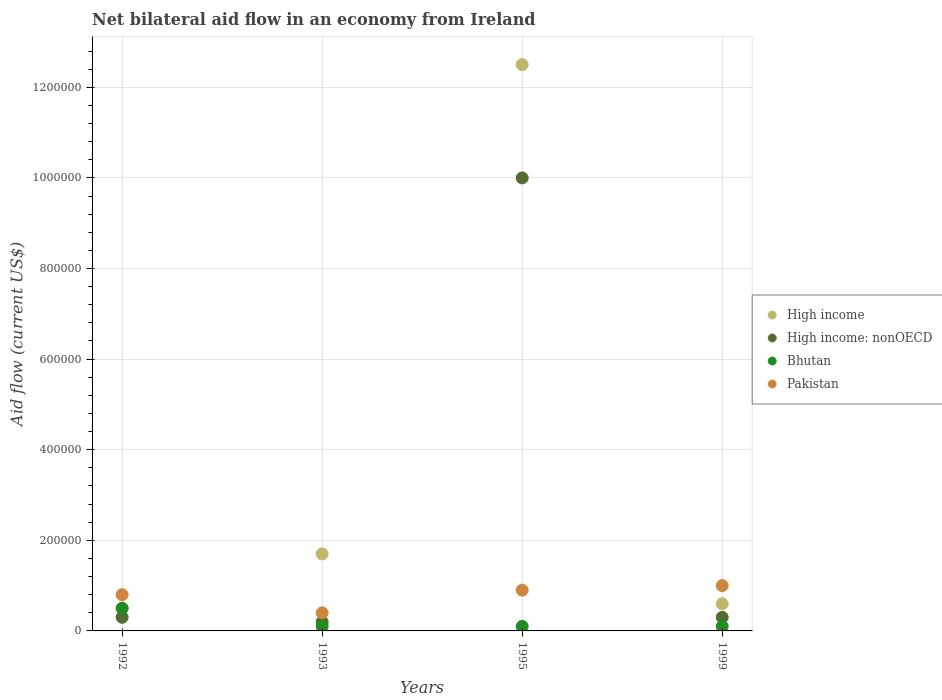How many different coloured dotlines are there?
Your answer should be very brief. 4. Across all years, what is the maximum net bilateral aid flow in High income: nonOECD?
Make the answer very short. 1.00e+06. Across all years, what is the minimum net bilateral aid flow in Bhutan?
Provide a short and direct response. 10000. In which year was the net bilateral aid flow in High income: nonOECD maximum?
Your response must be concise. 1995. In which year was the net bilateral aid flow in High income: nonOECD minimum?
Offer a very short reply. 1993. What is the difference between the net bilateral aid flow in High income: nonOECD in 1992 and that in 1995?
Keep it short and to the point. -9.70e+05. What is the difference between the net bilateral aid flow in Pakistan in 1992 and the net bilateral aid flow in High income in 1995?
Offer a very short reply. -1.17e+06. What is the average net bilateral aid flow in High income: nonOECD per year?
Your answer should be very brief. 2.70e+05. What is the ratio of the net bilateral aid flow in High income in 1993 to that in 1995?
Ensure brevity in your answer.  0.14. What is the difference between the highest and the second highest net bilateral aid flow in High income?
Your answer should be very brief. 1.08e+06. What is the difference between the highest and the lowest net bilateral aid flow in High income: nonOECD?
Your response must be concise. 9.80e+05. In how many years, is the net bilateral aid flow in High income: nonOECD greater than the average net bilateral aid flow in High income: nonOECD taken over all years?
Keep it short and to the point. 1. Is it the case that in every year, the sum of the net bilateral aid flow in High income: nonOECD and net bilateral aid flow in Bhutan  is greater than the sum of net bilateral aid flow in High income and net bilateral aid flow in Pakistan?
Provide a succinct answer. No. Does the net bilateral aid flow in Pakistan monotonically increase over the years?
Give a very brief answer. No. Is the net bilateral aid flow in Pakistan strictly greater than the net bilateral aid flow in Bhutan over the years?
Ensure brevity in your answer.  Yes. How many dotlines are there?
Make the answer very short. 4. What is the difference between two consecutive major ticks on the Y-axis?
Offer a very short reply. 2.00e+05. Are the values on the major ticks of Y-axis written in scientific E-notation?
Make the answer very short. No. Does the graph contain any zero values?
Ensure brevity in your answer.  No. How many legend labels are there?
Give a very brief answer. 4. What is the title of the graph?
Your answer should be compact. Net bilateral aid flow in an economy from Ireland. Does "Jamaica" appear as one of the legend labels in the graph?
Keep it short and to the point. No. What is the label or title of the X-axis?
Give a very brief answer. Years. What is the Aid flow (current US$) in Pakistan in 1992?
Provide a short and direct response. 8.00e+04. What is the Aid flow (current US$) in High income in 1993?
Your answer should be very brief. 1.70e+05. What is the Aid flow (current US$) of Bhutan in 1993?
Offer a very short reply. 10000. What is the Aid flow (current US$) in High income in 1995?
Provide a short and direct response. 1.25e+06. What is the Aid flow (current US$) in High income: nonOECD in 1995?
Keep it short and to the point. 1.00e+06. What is the Aid flow (current US$) in Bhutan in 1995?
Ensure brevity in your answer.  10000. What is the Aid flow (current US$) of High income in 1999?
Keep it short and to the point. 6.00e+04. What is the Aid flow (current US$) in Bhutan in 1999?
Ensure brevity in your answer.  10000. Across all years, what is the maximum Aid flow (current US$) in High income?
Your response must be concise. 1.25e+06. Across all years, what is the maximum Aid flow (current US$) of Bhutan?
Ensure brevity in your answer.  5.00e+04. Across all years, what is the maximum Aid flow (current US$) of Pakistan?
Offer a very short reply. 1.00e+05. Across all years, what is the minimum Aid flow (current US$) of High income?
Provide a short and direct response. 5.00e+04. What is the total Aid flow (current US$) in High income in the graph?
Provide a succinct answer. 1.53e+06. What is the total Aid flow (current US$) of High income: nonOECD in the graph?
Offer a very short reply. 1.08e+06. What is the total Aid flow (current US$) of Pakistan in the graph?
Make the answer very short. 3.10e+05. What is the difference between the Aid flow (current US$) of Bhutan in 1992 and that in 1993?
Offer a terse response. 4.00e+04. What is the difference between the Aid flow (current US$) of High income in 1992 and that in 1995?
Provide a short and direct response. -1.20e+06. What is the difference between the Aid flow (current US$) of High income: nonOECD in 1992 and that in 1995?
Give a very brief answer. -9.70e+05. What is the difference between the Aid flow (current US$) in Pakistan in 1992 and that in 1995?
Offer a terse response. -10000. What is the difference between the Aid flow (current US$) of High income in 1992 and that in 1999?
Keep it short and to the point. -10000. What is the difference between the Aid flow (current US$) of High income: nonOECD in 1992 and that in 1999?
Make the answer very short. 0. What is the difference between the Aid flow (current US$) of High income in 1993 and that in 1995?
Ensure brevity in your answer.  -1.08e+06. What is the difference between the Aid flow (current US$) in High income: nonOECD in 1993 and that in 1995?
Provide a short and direct response. -9.80e+05. What is the difference between the Aid flow (current US$) of Bhutan in 1993 and that in 1995?
Provide a succinct answer. 0. What is the difference between the Aid flow (current US$) in High income in 1993 and that in 1999?
Make the answer very short. 1.10e+05. What is the difference between the Aid flow (current US$) in High income: nonOECD in 1993 and that in 1999?
Your response must be concise. -10000. What is the difference between the Aid flow (current US$) of Pakistan in 1993 and that in 1999?
Your answer should be compact. -6.00e+04. What is the difference between the Aid flow (current US$) in High income in 1995 and that in 1999?
Offer a terse response. 1.19e+06. What is the difference between the Aid flow (current US$) in High income: nonOECD in 1995 and that in 1999?
Give a very brief answer. 9.70e+05. What is the difference between the Aid flow (current US$) in Bhutan in 1995 and that in 1999?
Provide a short and direct response. 0. What is the difference between the Aid flow (current US$) in High income: nonOECD in 1992 and the Aid flow (current US$) in Bhutan in 1993?
Keep it short and to the point. 2.00e+04. What is the difference between the Aid flow (current US$) in Bhutan in 1992 and the Aid flow (current US$) in Pakistan in 1993?
Your answer should be very brief. 10000. What is the difference between the Aid flow (current US$) of High income in 1992 and the Aid flow (current US$) of High income: nonOECD in 1995?
Provide a succinct answer. -9.50e+05. What is the difference between the Aid flow (current US$) of High income: nonOECD in 1992 and the Aid flow (current US$) of Pakistan in 1995?
Give a very brief answer. -6.00e+04. What is the difference between the Aid flow (current US$) of Bhutan in 1992 and the Aid flow (current US$) of Pakistan in 1995?
Provide a succinct answer. -4.00e+04. What is the difference between the Aid flow (current US$) in High income in 1992 and the Aid flow (current US$) in High income: nonOECD in 1999?
Offer a very short reply. 2.00e+04. What is the difference between the Aid flow (current US$) of High income in 1992 and the Aid flow (current US$) of Bhutan in 1999?
Your answer should be very brief. 4.00e+04. What is the difference between the Aid flow (current US$) of High income in 1992 and the Aid flow (current US$) of Pakistan in 1999?
Your answer should be very brief. -5.00e+04. What is the difference between the Aid flow (current US$) of High income in 1993 and the Aid flow (current US$) of High income: nonOECD in 1995?
Make the answer very short. -8.30e+05. What is the difference between the Aid flow (current US$) in High income in 1993 and the Aid flow (current US$) in Pakistan in 1995?
Give a very brief answer. 8.00e+04. What is the difference between the Aid flow (current US$) of High income: nonOECD in 1993 and the Aid flow (current US$) of Bhutan in 1995?
Provide a succinct answer. 10000. What is the difference between the Aid flow (current US$) of Bhutan in 1993 and the Aid flow (current US$) of Pakistan in 1995?
Ensure brevity in your answer.  -8.00e+04. What is the difference between the Aid flow (current US$) in High income in 1993 and the Aid flow (current US$) in High income: nonOECD in 1999?
Provide a short and direct response. 1.40e+05. What is the difference between the Aid flow (current US$) of High income in 1993 and the Aid flow (current US$) of Bhutan in 1999?
Offer a very short reply. 1.60e+05. What is the difference between the Aid flow (current US$) in High income: nonOECD in 1993 and the Aid flow (current US$) in Pakistan in 1999?
Your answer should be very brief. -8.00e+04. What is the difference between the Aid flow (current US$) of High income in 1995 and the Aid flow (current US$) of High income: nonOECD in 1999?
Your answer should be compact. 1.22e+06. What is the difference between the Aid flow (current US$) of High income in 1995 and the Aid flow (current US$) of Bhutan in 1999?
Offer a very short reply. 1.24e+06. What is the difference between the Aid flow (current US$) of High income in 1995 and the Aid flow (current US$) of Pakistan in 1999?
Make the answer very short. 1.15e+06. What is the difference between the Aid flow (current US$) of High income: nonOECD in 1995 and the Aid flow (current US$) of Bhutan in 1999?
Provide a succinct answer. 9.90e+05. What is the difference between the Aid flow (current US$) in Bhutan in 1995 and the Aid flow (current US$) in Pakistan in 1999?
Offer a very short reply. -9.00e+04. What is the average Aid flow (current US$) in High income per year?
Provide a succinct answer. 3.82e+05. What is the average Aid flow (current US$) of Pakistan per year?
Keep it short and to the point. 7.75e+04. In the year 1992, what is the difference between the Aid flow (current US$) of High income and Aid flow (current US$) of High income: nonOECD?
Your answer should be very brief. 2.00e+04. In the year 1992, what is the difference between the Aid flow (current US$) of High income and Aid flow (current US$) of Bhutan?
Offer a terse response. 0. In the year 1992, what is the difference between the Aid flow (current US$) of High income: nonOECD and Aid flow (current US$) of Bhutan?
Make the answer very short. -2.00e+04. In the year 1992, what is the difference between the Aid flow (current US$) in High income: nonOECD and Aid flow (current US$) in Pakistan?
Your response must be concise. -5.00e+04. In the year 1993, what is the difference between the Aid flow (current US$) in High income and Aid flow (current US$) in Bhutan?
Ensure brevity in your answer.  1.60e+05. In the year 1993, what is the difference between the Aid flow (current US$) of High income and Aid flow (current US$) of Pakistan?
Keep it short and to the point. 1.30e+05. In the year 1993, what is the difference between the Aid flow (current US$) in Bhutan and Aid flow (current US$) in Pakistan?
Offer a very short reply. -3.00e+04. In the year 1995, what is the difference between the Aid flow (current US$) in High income and Aid flow (current US$) in High income: nonOECD?
Provide a short and direct response. 2.50e+05. In the year 1995, what is the difference between the Aid flow (current US$) in High income and Aid flow (current US$) in Bhutan?
Give a very brief answer. 1.24e+06. In the year 1995, what is the difference between the Aid flow (current US$) in High income and Aid flow (current US$) in Pakistan?
Offer a terse response. 1.16e+06. In the year 1995, what is the difference between the Aid flow (current US$) of High income: nonOECD and Aid flow (current US$) of Bhutan?
Give a very brief answer. 9.90e+05. In the year 1995, what is the difference between the Aid flow (current US$) in High income: nonOECD and Aid flow (current US$) in Pakistan?
Keep it short and to the point. 9.10e+05. In the year 1995, what is the difference between the Aid flow (current US$) of Bhutan and Aid flow (current US$) of Pakistan?
Your response must be concise. -8.00e+04. In the year 1999, what is the difference between the Aid flow (current US$) of High income and Aid flow (current US$) of Pakistan?
Provide a succinct answer. -4.00e+04. In the year 1999, what is the difference between the Aid flow (current US$) of High income: nonOECD and Aid flow (current US$) of Pakistan?
Offer a terse response. -7.00e+04. In the year 1999, what is the difference between the Aid flow (current US$) of Bhutan and Aid flow (current US$) of Pakistan?
Ensure brevity in your answer.  -9.00e+04. What is the ratio of the Aid flow (current US$) in High income in 1992 to that in 1993?
Provide a succinct answer. 0.29. What is the ratio of the Aid flow (current US$) of Bhutan in 1992 to that in 1993?
Your answer should be compact. 5. What is the ratio of the Aid flow (current US$) in Pakistan in 1992 to that in 1993?
Make the answer very short. 2. What is the ratio of the Aid flow (current US$) of High income in 1992 to that in 1995?
Offer a very short reply. 0.04. What is the ratio of the Aid flow (current US$) in High income: nonOECD in 1992 to that in 1995?
Keep it short and to the point. 0.03. What is the ratio of the Aid flow (current US$) in Bhutan in 1992 to that in 1995?
Offer a very short reply. 5. What is the ratio of the Aid flow (current US$) of Pakistan in 1992 to that in 1995?
Your answer should be very brief. 0.89. What is the ratio of the Aid flow (current US$) in High income in 1992 to that in 1999?
Ensure brevity in your answer.  0.83. What is the ratio of the Aid flow (current US$) in High income: nonOECD in 1992 to that in 1999?
Make the answer very short. 1. What is the ratio of the Aid flow (current US$) in Pakistan in 1992 to that in 1999?
Offer a very short reply. 0.8. What is the ratio of the Aid flow (current US$) of High income in 1993 to that in 1995?
Keep it short and to the point. 0.14. What is the ratio of the Aid flow (current US$) of High income: nonOECD in 1993 to that in 1995?
Offer a terse response. 0.02. What is the ratio of the Aid flow (current US$) in Bhutan in 1993 to that in 1995?
Provide a short and direct response. 1. What is the ratio of the Aid flow (current US$) of Pakistan in 1993 to that in 1995?
Keep it short and to the point. 0.44. What is the ratio of the Aid flow (current US$) in High income in 1993 to that in 1999?
Offer a very short reply. 2.83. What is the ratio of the Aid flow (current US$) of Pakistan in 1993 to that in 1999?
Your answer should be compact. 0.4. What is the ratio of the Aid flow (current US$) in High income in 1995 to that in 1999?
Your answer should be compact. 20.83. What is the ratio of the Aid flow (current US$) in High income: nonOECD in 1995 to that in 1999?
Your response must be concise. 33.33. What is the ratio of the Aid flow (current US$) in Bhutan in 1995 to that in 1999?
Your answer should be compact. 1. What is the difference between the highest and the second highest Aid flow (current US$) in High income?
Your answer should be very brief. 1.08e+06. What is the difference between the highest and the second highest Aid flow (current US$) in High income: nonOECD?
Your response must be concise. 9.70e+05. What is the difference between the highest and the second highest Aid flow (current US$) of Pakistan?
Offer a terse response. 10000. What is the difference between the highest and the lowest Aid flow (current US$) in High income?
Give a very brief answer. 1.20e+06. What is the difference between the highest and the lowest Aid flow (current US$) of High income: nonOECD?
Offer a terse response. 9.80e+05. What is the difference between the highest and the lowest Aid flow (current US$) of Bhutan?
Provide a succinct answer. 4.00e+04. What is the difference between the highest and the lowest Aid flow (current US$) in Pakistan?
Your answer should be compact. 6.00e+04. 